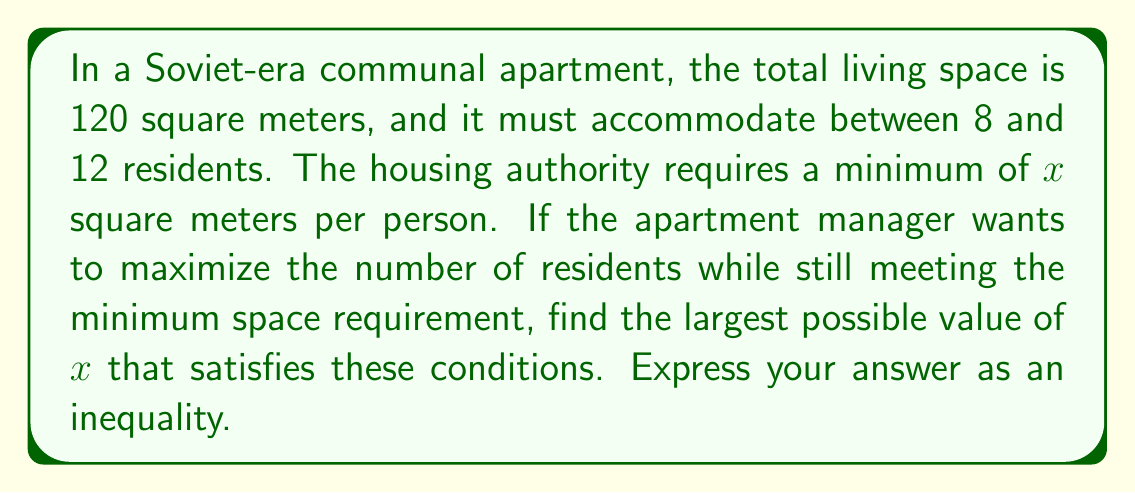Show me your answer to this math problem. Let's approach this step-by-step:

1) Let $n$ be the number of residents. We know that $8 \leq n \leq 12$.

2) The total area is 120 square meters, and each person must have at least $x$ square meters. This means:

   $nx \leq 120$

3) We want to find the largest possible $x$ that works for all possible values of $n$. The most restrictive case will be when $n$ is at its minimum value, 8.

4) Substituting $n = 8$ into the inequality:

   $8x \leq 120$

5) Solving for $x$:

   $x \leq 120 / 8 = 15$

6) Therefore, $x$ must be less than or equal to 15 for the inequality to hold true for all possible values of $n$.

7) To express this as an inequality with $x$ on the left side:

   $0 < x \leq 15$

   The lower bound of 0 is included because a negative living space is not meaningful.
Answer: $0 < x \leq 15$ 